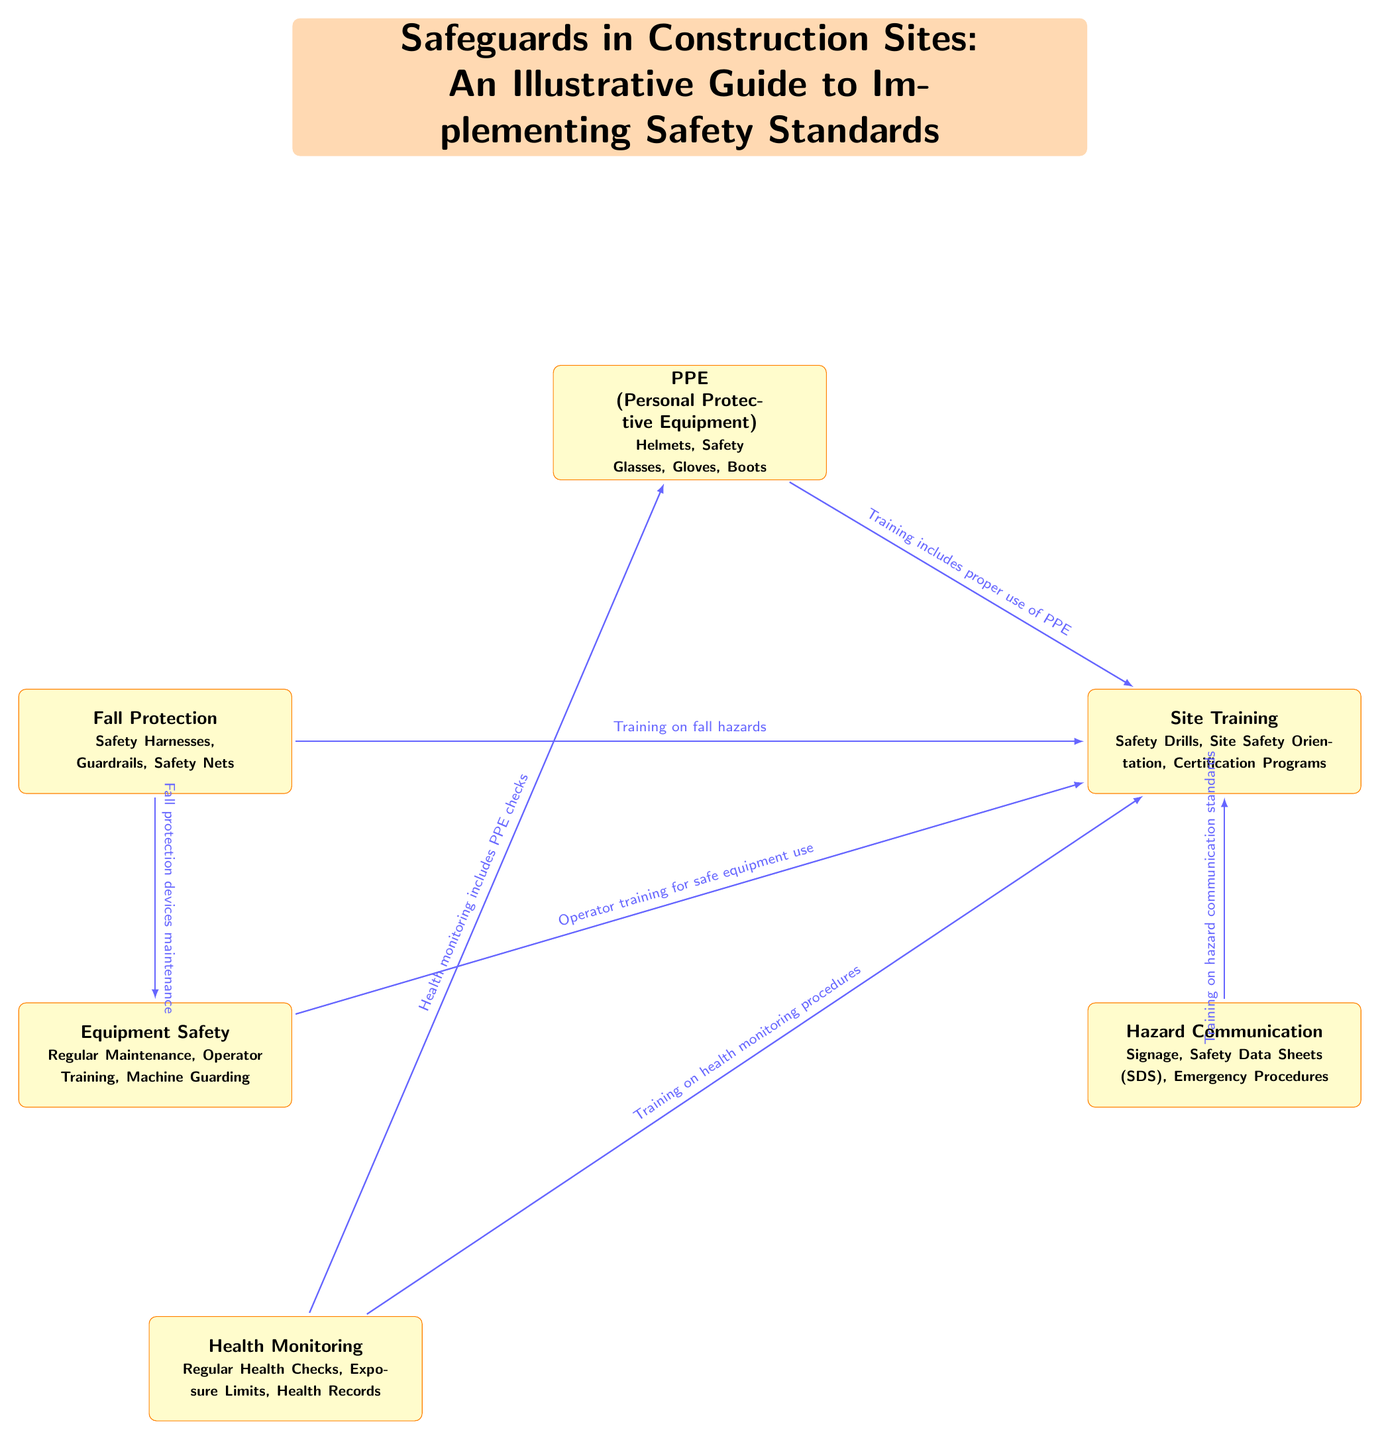What are the components listed under PPE? The diagram states that PPE includes Helmets, Safety Glasses, Gloves, and Boots. These components are specified in the node for Personal Protective Equipment, which is positioned below the title.
Answer: Helmets, Safety Glasses, Gloves, Boots How many main safety categories are represented in the diagram? The diagram visually presents six main safety categories, which can be counted as individual boxes starting from the node for Personal Protective Equipment to Health Monitoring.
Answer: Six Which node is directly connected to Site Training? The Site Training node has direct connections to both the Hazard Communication and Equipment Safety nodes. This is determined by observing the arrows connecting these nodes on the diagram.
Answer: Hazard Communication, Equipment Safety What is the main focus of the Fall Protection category? The Fall Protection node emphasizes that it includes Safety Harnesses, Guardrails, and Safety Nets. These are key components specifically mentioned under the Fall Protection category on the diagram.
Answer: Safety Harnesses, Guardrails, Safety Nets Which two categories include training as a significant element? The diagram indicates that both Site Training and Fall Protection include training. The connections to these categories are labelled with phrases about training in relevance to their safety aspects.
Answer: Site Training, Fall Protection What is emphasized in the relationship between Equipment Safety and Site Training? The connection between Equipment Safety and Site Training highlights that Operator training is crucial for safe equipment use, as stated in the arrow label connecting these two nodes.
Answer: Operator training for safe equipment use 